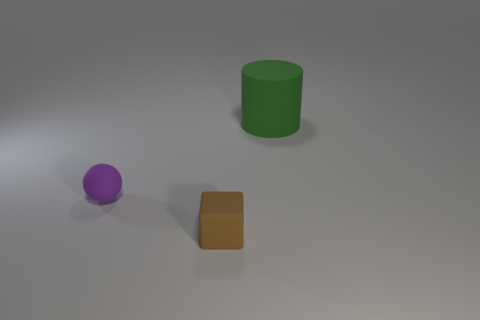How many objects are things that are on the left side of the brown rubber object or things on the left side of the rubber cylinder?
Your answer should be very brief. 2. Is the size of the matte cube the same as the cylinder?
Offer a very short reply. No. Is the number of small purple things greater than the number of cyan shiny balls?
Provide a short and direct response. Yes. How many other objects are the same color as the cylinder?
Give a very brief answer. 0. How many objects are big brown cylinders or small objects?
Your response must be concise. 2. There is a object that is in front of the small thing to the left of the brown thing; what color is it?
Offer a very short reply. Brown. Is the number of purple spheres less than the number of tiny cyan cubes?
Offer a very short reply. No. Are there any large brown things that have the same material as the sphere?
Your response must be concise. No. Are there any large cylinders on the left side of the tiny purple thing?
Keep it short and to the point. No. What number of small brown rubber things have the same shape as the green thing?
Your response must be concise. 0. 